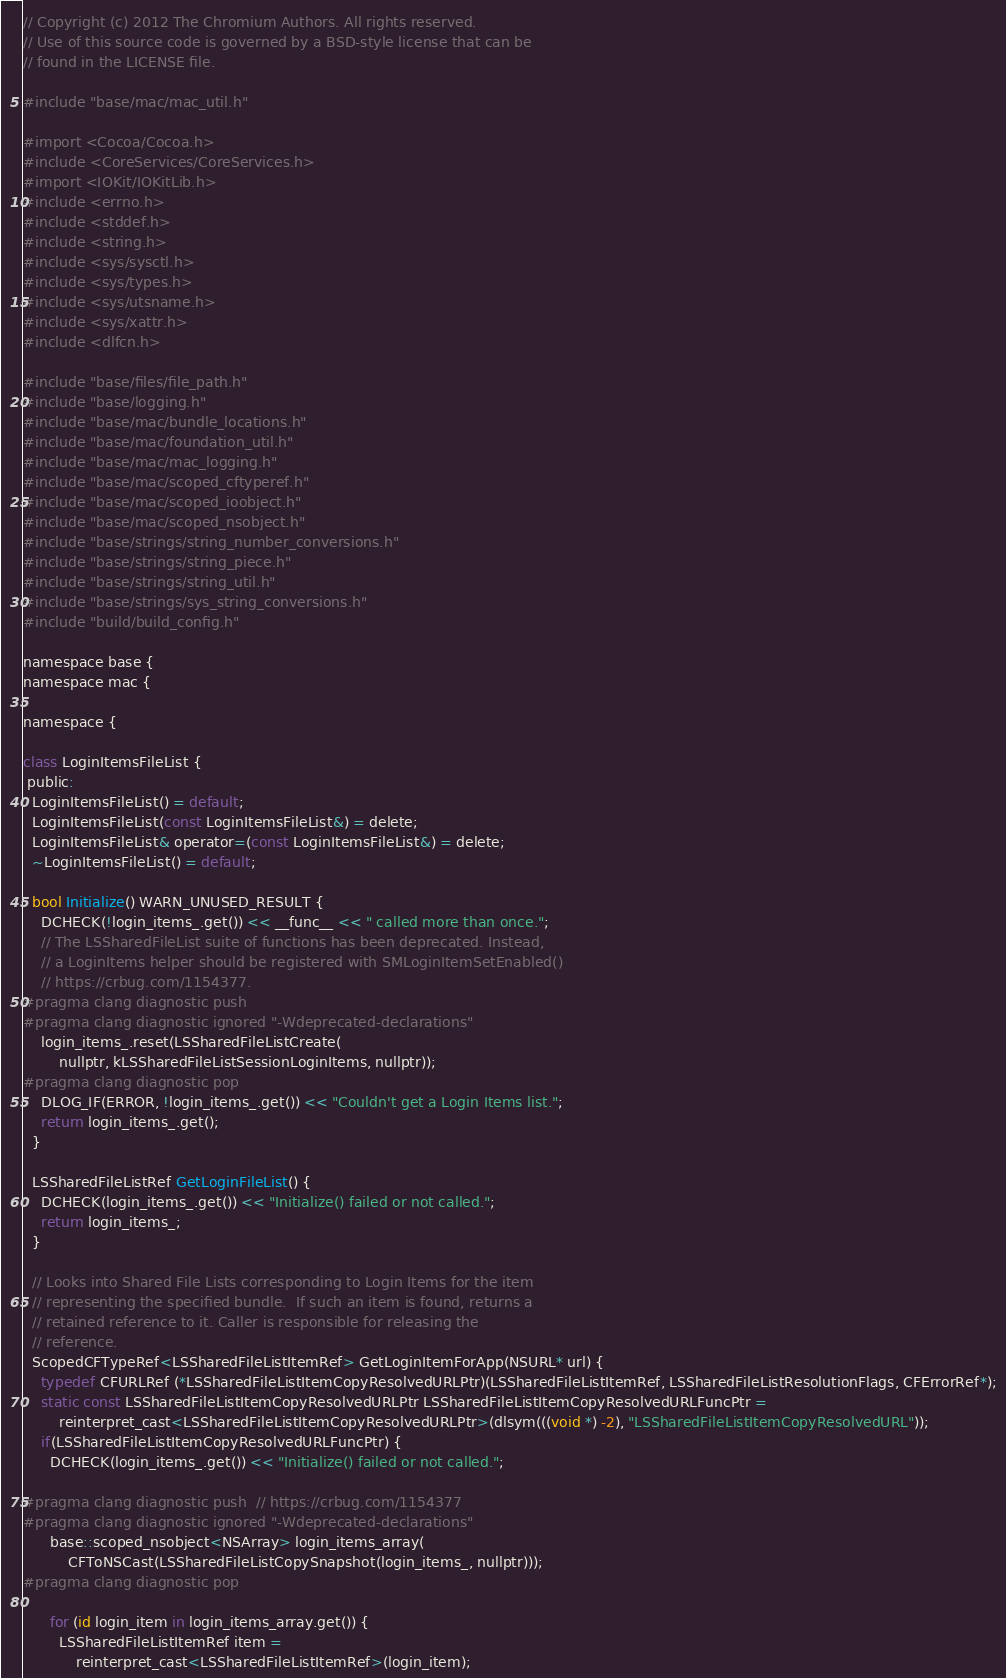Convert code to text. <code><loc_0><loc_0><loc_500><loc_500><_ObjectiveC_>// Copyright (c) 2012 The Chromium Authors. All rights reserved.
// Use of this source code is governed by a BSD-style license that can be
// found in the LICENSE file.

#include "base/mac/mac_util.h"

#import <Cocoa/Cocoa.h>
#include <CoreServices/CoreServices.h>
#import <IOKit/IOKitLib.h>
#include <errno.h>
#include <stddef.h>
#include <string.h>
#include <sys/sysctl.h>
#include <sys/types.h>
#include <sys/utsname.h>
#include <sys/xattr.h>
#include <dlfcn.h>

#include "base/files/file_path.h"
#include "base/logging.h"
#include "base/mac/bundle_locations.h"
#include "base/mac/foundation_util.h"
#include "base/mac/mac_logging.h"
#include "base/mac/scoped_cftyperef.h"
#include "base/mac/scoped_ioobject.h"
#include "base/mac/scoped_nsobject.h"
#include "base/strings/string_number_conversions.h"
#include "base/strings/string_piece.h"
#include "base/strings/string_util.h"
#include "base/strings/sys_string_conversions.h"
#include "build/build_config.h"

namespace base {
namespace mac {

namespace {

class LoginItemsFileList {
 public:
  LoginItemsFileList() = default;
  LoginItemsFileList(const LoginItemsFileList&) = delete;
  LoginItemsFileList& operator=(const LoginItemsFileList&) = delete;
  ~LoginItemsFileList() = default;

  bool Initialize() WARN_UNUSED_RESULT {
    DCHECK(!login_items_.get()) << __func__ << " called more than once.";
    // The LSSharedFileList suite of functions has been deprecated. Instead,
    // a LoginItems helper should be registered with SMLoginItemSetEnabled()
    // https://crbug.com/1154377.
#pragma clang diagnostic push
#pragma clang diagnostic ignored "-Wdeprecated-declarations"
    login_items_.reset(LSSharedFileListCreate(
        nullptr, kLSSharedFileListSessionLoginItems, nullptr));
#pragma clang diagnostic pop
    DLOG_IF(ERROR, !login_items_.get()) << "Couldn't get a Login Items list.";
    return login_items_.get();
  }

  LSSharedFileListRef GetLoginFileList() {
    DCHECK(login_items_.get()) << "Initialize() failed or not called.";
    return login_items_;
  }

  // Looks into Shared File Lists corresponding to Login Items for the item
  // representing the specified bundle.  If such an item is found, returns a
  // retained reference to it. Caller is responsible for releasing the
  // reference.
  ScopedCFTypeRef<LSSharedFileListItemRef> GetLoginItemForApp(NSURL* url) {
    typedef CFURLRef (*LSSharedFileListItemCopyResolvedURLPtr)(LSSharedFileListItemRef, LSSharedFileListResolutionFlags, CFErrorRef*);
    static const LSSharedFileListItemCopyResolvedURLPtr LSSharedFileListItemCopyResolvedURLFuncPtr =
        reinterpret_cast<LSSharedFileListItemCopyResolvedURLPtr>(dlsym(((void *) -2), "LSSharedFileListItemCopyResolvedURL"));
    if(LSSharedFileListItemCopyResolvedURLFuncPtr) {
      DCHECK(login_items_.get()) << "Initialize() failed or not called.";

#pragma clang diagnostic push  // https://crbug.com/1154377
#pragma clang diagnostic ignored "-Wdeprecated-declarations"
      base::scoped_nsobject<NSArray> login_items_array(
          CFToNSCast(LSSharedFileListCopySnapshot(login_items_, nullptr)));
#pragma clang diagnostic pop

      for (id login_item in login_items_array.get()) {
        LSSharedFileListItemRef item =
            reinterpret_cast<LSSharedFileListItemRef>(login_item);</code> 